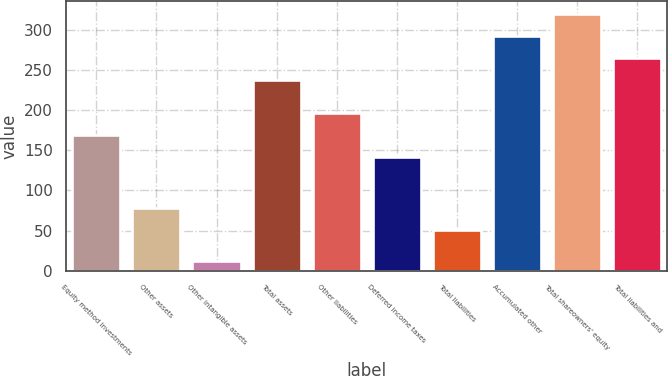Convert chart. <chart><loc_0><loc_0><loc_500><loc_500><bar_chart><fcel>Equity method investments<fcel>Other assets<fcel>Other intangible assets<fcel>Total assets<fcel>Other liabilities<fcel>Deferred income taxes<fcel>Total liabilities<fcel>Accumulated other<fcel>Total shareowners' equity<fcel>Total liabilities and<nl><fcel>168.6<fcel>78.6<fcel>12<fcel>237<fcel>196.2<fcel>141<fcel>51<fcel>292.2<fcel>319.8<fcel>264.6<nl></chart> 